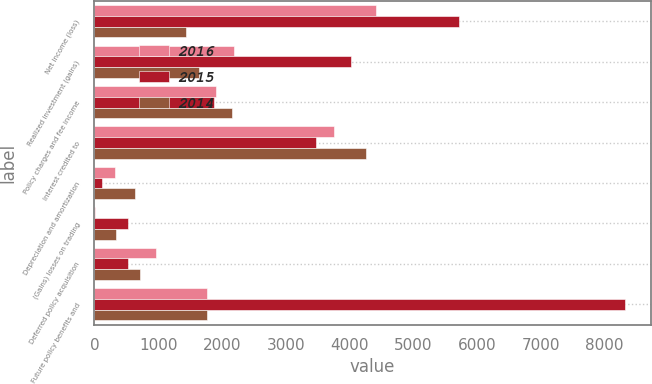Convert chart. <chart><loc_0><loc_0><loc_500><loc_500><stacked_bar_chart><ecel><fcel>Net income (loss)<fcel>Realized investment (gains)<fcel>Policy charges and fee income<fcel>Interest credited to<fcel>Depreciation and amortization<fcel>(Gains) losses on trading<fcel>Deferred policy acquisition<fcel>Future policy benefits and<nl><fcel>2016<fcel>4419<fcel>2194<fcel>1907<fcel>3761<fcel>318<fcel>17<fcel>968<fcel>1759.5<nl><fcel>2015<fcel>5712<fcel>4025<fcel>1883<fcel>3479<fcel>113<fcel>524<fcel>533<fcel>8311<nl><fcel>2014<fcel>1438<fcel>1636<fcel>2156<fcel>4263<fcel>631<fcel>339<fcel>721<fcel>1759.5<nl></chart> 